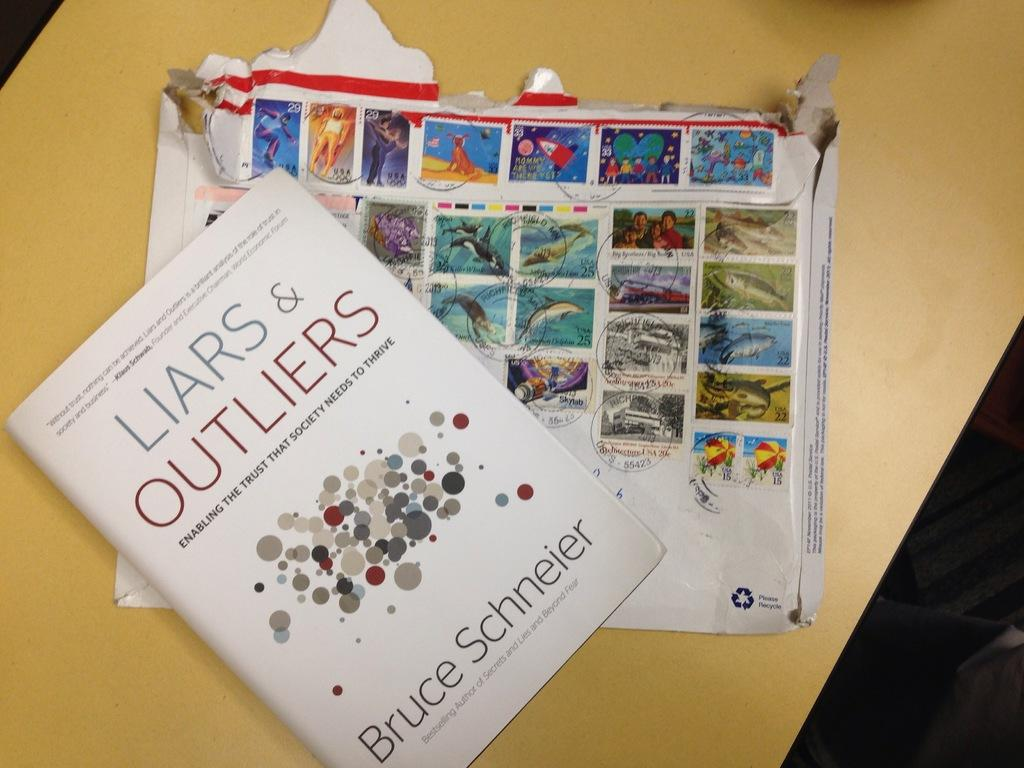<image>
Create a compact narrative representing the image presented. A book titled Liars and outliers by Bruce Schneier. 